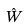<formula> <loc_0><loc_0><loc_500><loc_500>\hat { W }</formula> 